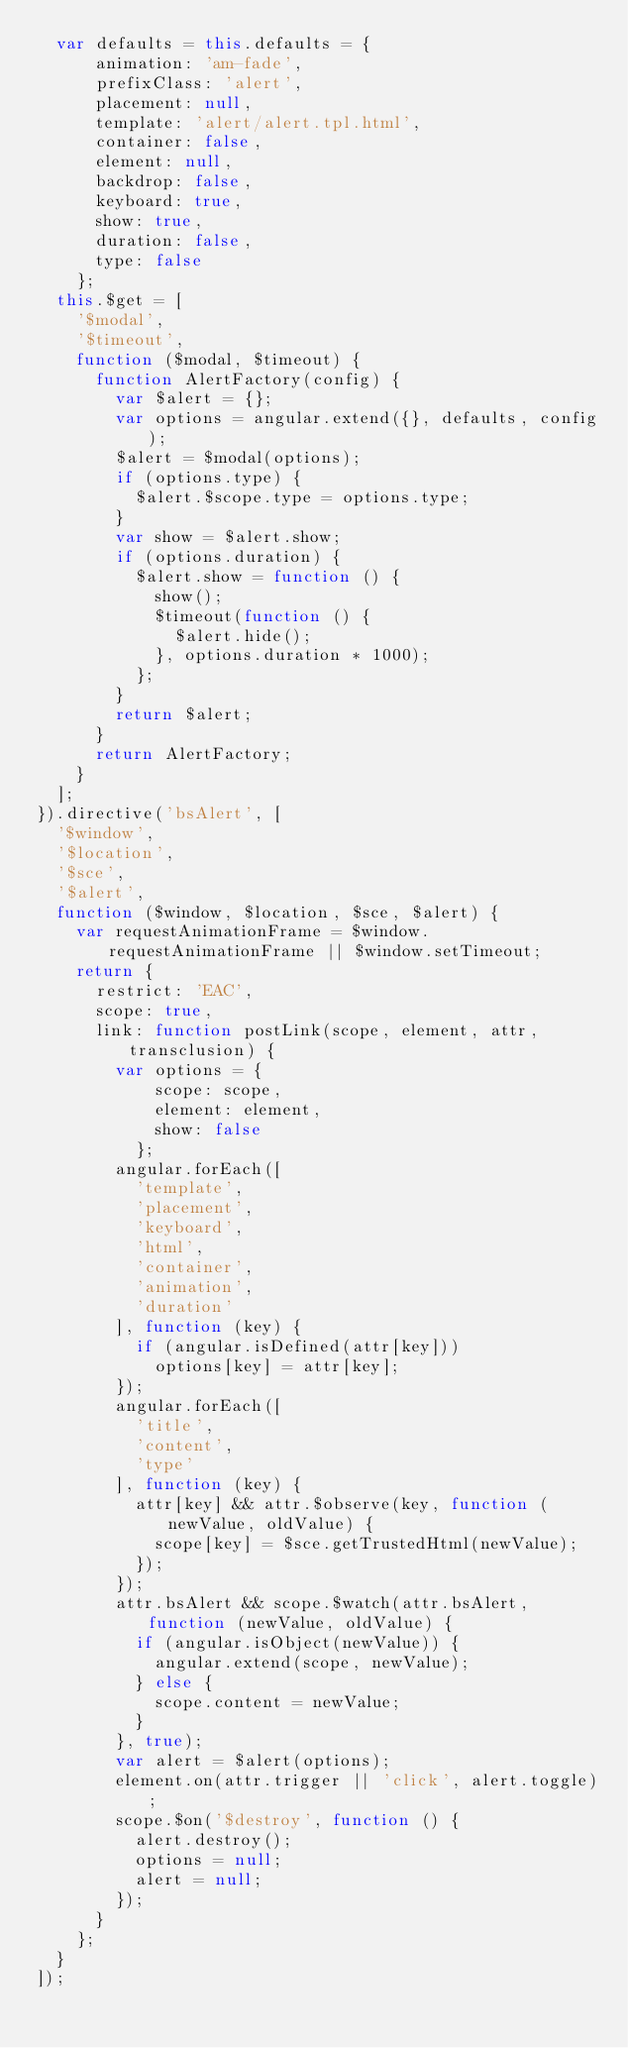Convert code to text. <code><loc_0><loc_0><loc_500><loc_500><_JavaScript_>  var defaults = this.defaults = {
      animation: 'am-fade',
      prefixClass: 'alert',
      placement: null,
      template: 'alert/alert.tpl.html',
      container: false,
      element: null,
      backdrop: false,
      keyboard: true,
      show: true,
      duration: false,
      type: false
    };
  this.$get = [
    '$modal',
    '$timeout',
    function ($modal, $timeout) {
      function AlertFactory(config) {
        var $alert = {};
        var options = angular.extend({}, defaults, config);
        $alert = $modal(options);
        if (options.type) {
          $alert.$scope.type = options.type;
        }
        var show = $alert.show;
        if (options.duration) {
          $alert.show = function () {
            show();
            $timeout(function () {
              $alert.hide();
            }, options.duration * 1000);
          };
        }
        return $alert;
      }
      return AlertFactory;
    }
  ];
}).directive('bsAlert', [
  '$window',
  '$location',
  '$sce',
  '$alert',
  function ($window, $location, $sce, $alert) {
    var requestAnimationFrame = $window.requestAnimationFrame || $window.setTimeout;
    return {
      restrict: 'EAC',
      scope: true,
      link: function postLink(scope, element, attr, transclusion) {
        var options = {
            scope: scope,
            element: element,
            show: false
          };
        angular.forEach([
          'template',
          'placement',
          'keyboard',
          'html',
          'container',
          'animation',
          'duration'
        ], function (key) {
          if (angular.isDefined(attr[key]))
            options[key] = attr[key];
        });
        angular.forEach([
          'title',
          'content',
          'type'
        ], function (key) {
          attr[key] && attr.$observe(key, function (newValue, oldValue) {
            scope[key] = $sce.getTrustedHtml(newValue);
          });
        });
        attr.bsAlert && scope.$watch(attr.bsAlert, function (newValue, oldValue) {
          if (angular.isObject(newValue)) {
            angular.extend(scope, newValue);
          } else {
            scope.content = newValue;
          }
        }, true);
        var alert = $alert(options);
        element.on(attr.trigger || 'click', alert.toggle);
        scope.$on('$destroy', function () {
          alert.destroy();
          options = null;
          alert = null;
        });
      }
    };
  }
]);</code> 